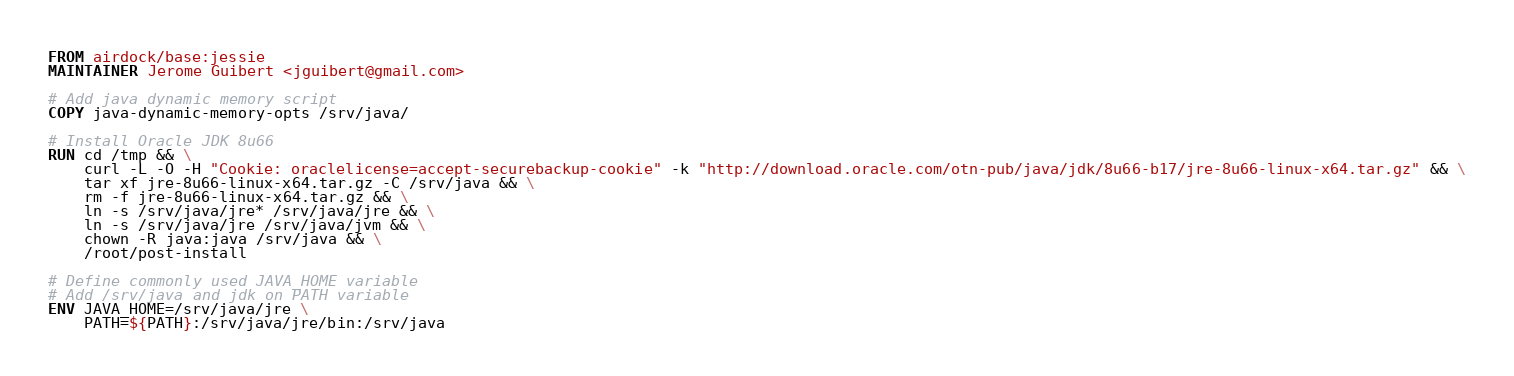Convert code to text. <code><loc_0><loc_0><loc_500><loc_500><_Dockerfile_>FROM airdock/base:jessie
MAINTAINER Jerome Guibert <jguibert@gmail.com>

# Add java dynamic memory script
COPY java-dynamic-memory-opts /srv/java/

# Install Oracle JDK 8u66
RUN cd /tmp && \
    curl -L -O -H "Cookie: oraclelicense=accept-securebackup-cookie" -k "http://download.oracle.com/otn-pub/java/jdk/8u66-b17/jre-8u66-linux-x64.tar.gz" && \
    tar xf jre-8u66-linux-x64.tar.gz -C /srv/java && \
    rm -f jre-8u66-linux-x64.tar.gz && \
    ln -s /srv/java/jre* /srv/java/jre && \
    ln -s /srv/java/jre /srv/java/jvm && \
    chown -R java:java /srv/java && \
    /root/post-install

# Define commonly used JAVA_HOME variable
# Add /srv/java and jdk on PATH variable
ENV JAVA_HOME=/srv/java/jre \
    PATH=${PATH}:/srv/java/jre/bin:/srv/java
</code> 